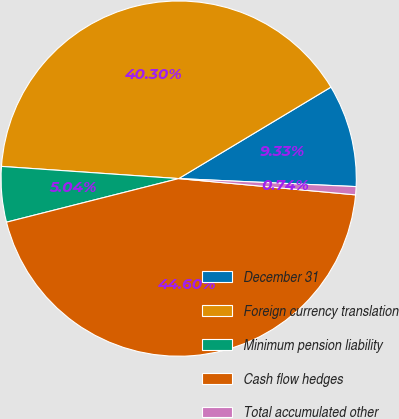Convert chart. <chart><loc_0><loc_0><loc_500><loc_500><pie_chart><fcel>December 31<fcel>Foreign currency translation<fcel>Minimum pension liability<fcel>Cash flow hedges<fcel>Total accumulated other<nl><fcel>9.33%<fcel>40.3%<fcel>5.04%<fcel>44.6%<fcel>0.74%<nl></chart> 